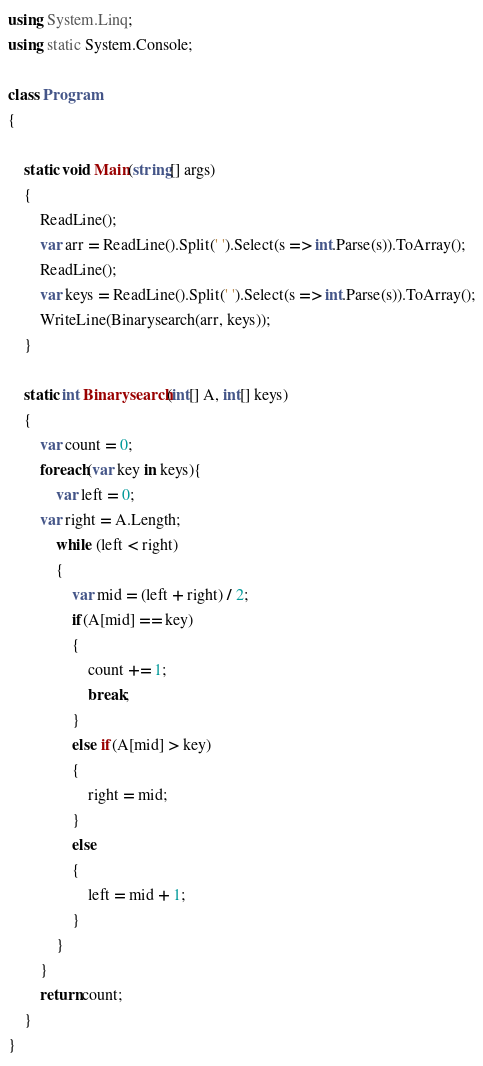Convert code to text. <code><loc_0><loc_0><loc_500><loc_500><_C#_>using System.Linq;
using static System.Console;

class Program
{
    
    static void Main(string[] args)
    {
        ReadLine();
        var arr = ReadLine().Split(' ').Select(s => int.Parse(s)).ToArray();
        ReadLine();
        var keys = ReadLine().Split(' ').Select(s => int.Parse(s)).ToArray();
        WriteLine(Binarysearch(arr, keys));
    }

    static int Binarysearch(int[] A, int[] keys)
    {
        var count = 0;
    	foreach(var key in keys){
            var left = 0;
	    var right = A.Length;
            while (left < right)
            {
                var mid = (left + right) / 2;
                if(A[mid] == key)
                {
                    count += 1;
                    break;
                }
                else if(A[mid] > key)
                {
                    right = mid;
                }
                else
                {
                    left = mid + 1;
                }
            }
    	}
    	return count;
    }
}
</code> 